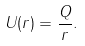<formula> <loc_0><loc_0><loc_500><loc_500>U ( r ) = \frac { Q } { r } .</formula> 